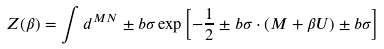<formula> <loc_0><loc_0><loc_500><loc_500>Z ( \beta ) = \int d ^ { M N } \pm b \sigma \exp \left [ - \frac { 1 } { 2 } \pm b \sigma \cdot ( M + \beta U ) \pm b \sigma \right ]</formula> 